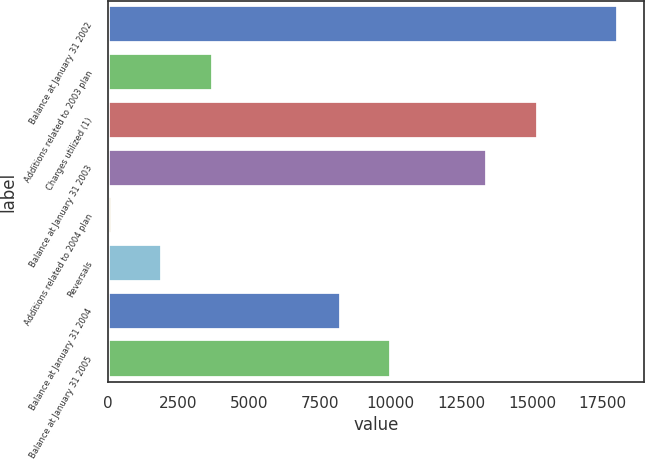<chart> <loc_0><loc_0><loc_500><loc_500><bar_chart><fcel>Balance at January 31 2002<fcel>Additions related to 2003 plan<fcel>Charges utilized (1)<fcel>Balance at January 31 2003<fcel>Additions related to 2004 plan<fcel>Reversals<fcel>Balance at January 31 2004<fcel>Balance at January 31 2005<nl><fcel>18044<fcel>3728<fcel>15195.5<fcel>13406<fcel>149<fcel>1938.5<fcel>8236<fcel>10025.5<nl></chart> 